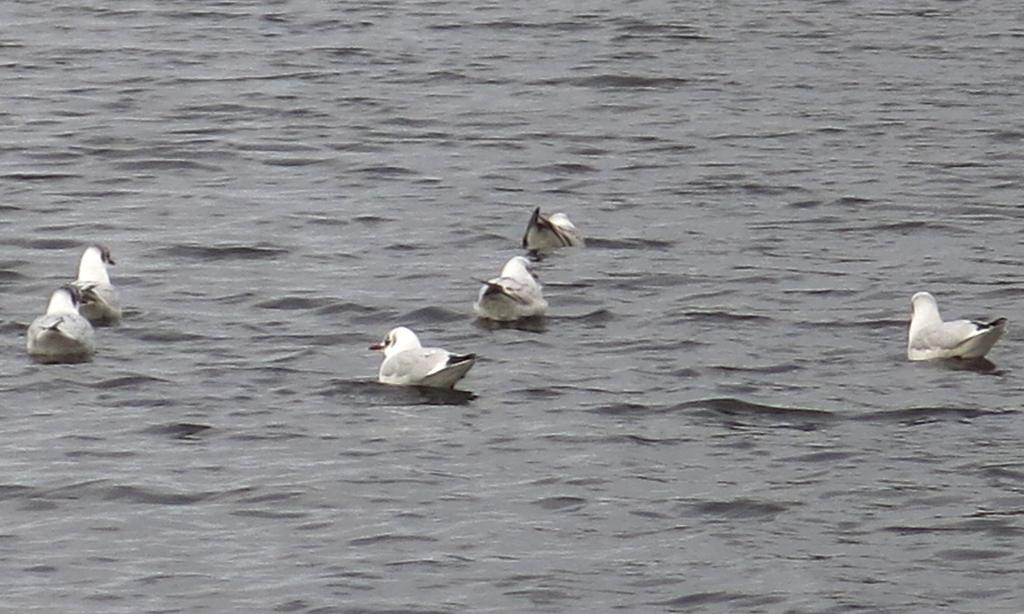What is the primary element in the picture? There is water in the picture. What type of animals are in the water? There are birds in the water. What color are the birds? The birds are white in color. What is the color of the birds' tails? The birds have black tails. What position does the loaf of bread hold in the image? There is no loaf of bread present in the image. How many family members can be seen in the image? There is no reference to a family or family members in the image. 